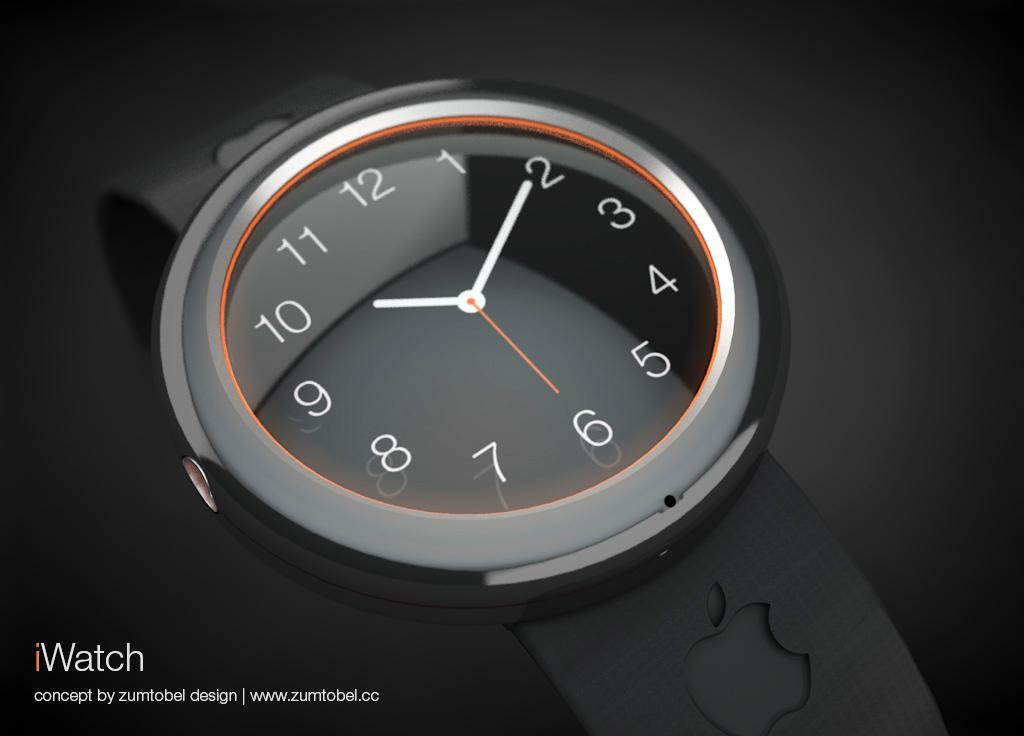What object is the main focus of the image? There is a watch in the image. How is the watch depicted in the image? The watch is truncated towards the bottom of the image. What else can be seen towards the bottom of the image? There is text towards the bottom of the image. What is the color of the background in the image? The background of the image is dark. What type of meal is being served at the zoo in the image? There is no meal or zoo present in the image; it features a watch with truncated edges and text at the bottom. What is the range of the watch's capabilities in the image? The image does not show the watch's capabilities or range, as it only depicts the watch's appearance. 